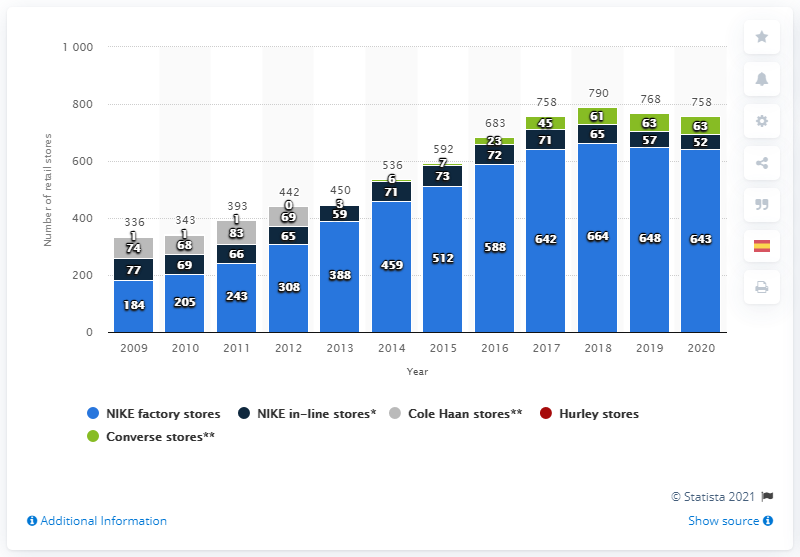Specify some key components in this picture. In 2020, Nike operated 643 factory stores outside of the United States, demonstrating its global reach and expansion in the retail market. 